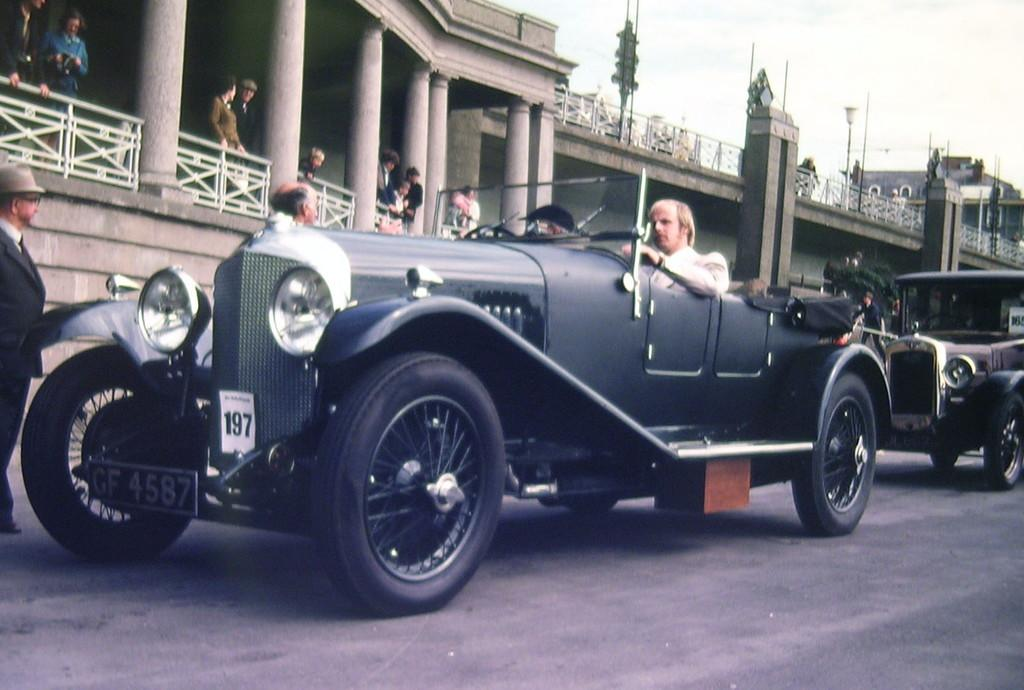What can be seen on the road in the image? There are two vehicles on the road in the image. What is happening inside the building in the image? There is a group of people standing in a building in the image. How many ants can be seen crawling on the elbow of the person in the image? There are no ants or elbows visible in the image. What is the weather like during the rainstorm in the image? There is no rainstorm present in the image. 